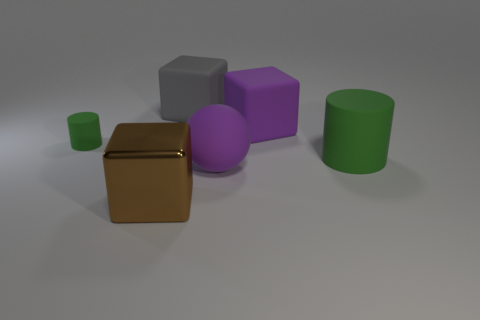Add 1 purple matte objects. How many objects exist? 7 Subtract all gray cubes. How many cubes are left? 2 Subtract 2 cylinders. How many cylinders are left? 0 Subtract all spheres. How many objects are left? 5 Subtract all purple spheres. How many purple cubes are left? 1 Subtract all big balls. Subtract all gray matte objects. How many objects are left? 4 Add 4 purple matte blocks. How many purple matte blocks are left? 5 Add 3 tiny green cylinders. How many tiny green cylinders exist? 4 Subtract 0 red cylinders. How many objects are left? 6 Subtract all green blocks. Subtract all green balls. How many blocks are left? 3 